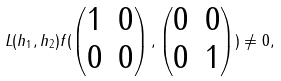<formula> <loc_0><loc_0><loc_500><loc_500>L ( h _ { 1 } , h _ { 2 } ) f ( \begin{pmatrix} 1 & 0 \\ 0 & 0 \end{pmatrix} , \begin{pmatrix} 0 & 0 \\ 0 & 1 \end{pmatrix} ) \ne 0 ,</formula> 